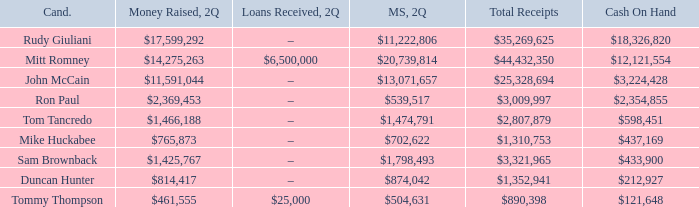Give me the full table as a dictionary. {'header': ['Cand.', 'Money Raised, 2Q', 'Loans Received, 2Q', 'MS, 2Q', 'Total Receipts', 'Cash On Hand'], 'rows': [['Rudy Giuliani', '$17,599,292', '–', '$11,222,806', '$35,269,625', '$18,326,820'], ['Mitt Romney', '$14,275,263', '$6,500,000', '$20,739,814', '$44,432,350', '$12,121,554'], ['John McCain', '$11,591,044', '–', '$13,071,657', '$25,328,694', '$3,224,428'], ['Ron Paul', '$2,369,453', '–', '$539,517', '$3,009,997', '$2,354,855'], ['Tom Tancredo', '$1,466,188', '–', '$1,474,791', '$2,807,879', '$598,451'], ['Mike Huckabee', '$765,873', '–', '$702,622', '$1,310,753', '$437,169'], ['Sam Brownback', '$1,425,767', '–', '$1,798,493', '$3,321,965', '$433,900'], ['Duncan Hunter', '$814,417', '–', '$874,042', '$1,352,941', '$212,927'], ['Tommy Thompson', '$461,555', '$25,000', '$504,631', '$890,398', '$121,648']]} Name the money raised when 2Q has money spent and 2Q is $874,042 $814,417. 